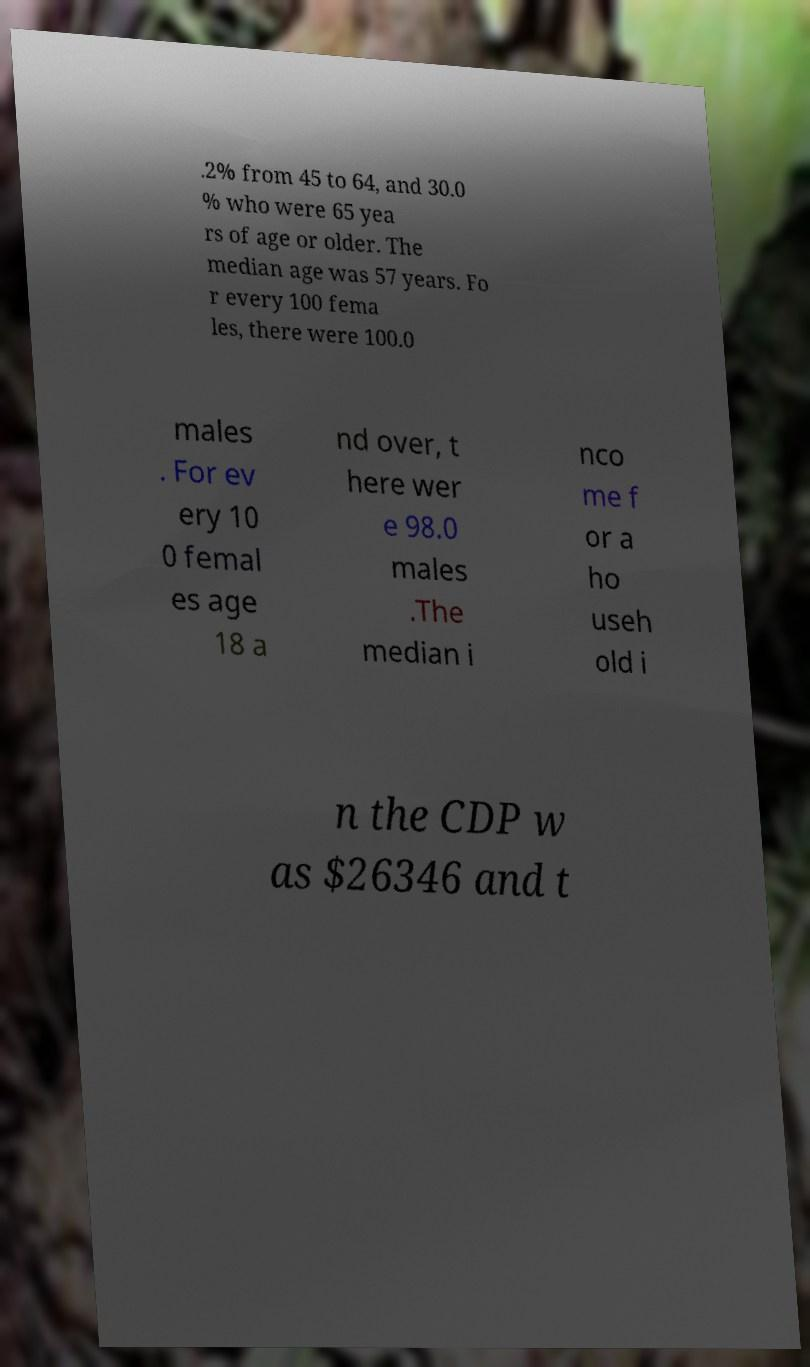Can you accurately transcribe the text from the provided image for me? .2% from 45 to 64, and 30.0 % who were 65 yea rs of age or older. The median age was 57 years. Fo r every 100 fema les, there were 100.0 males . For ev ery 10 0 femal es age 18 a nd over, t here wer e 98.0 males .The median i nco me f or a ho useh old i n the CDP w as $26346 and t 